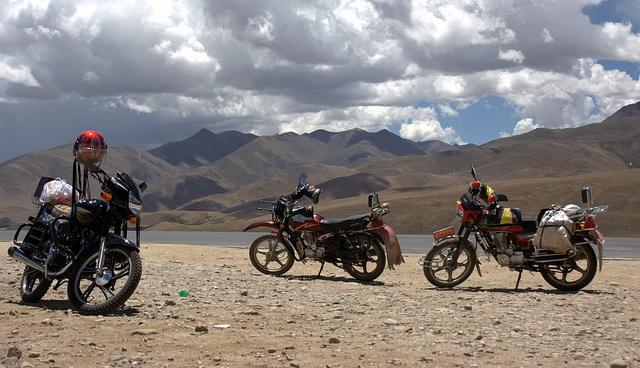Describe the objects in this image and their specific colors. I can see motorcycle in lightgray, black, gray, darkgray, and maroon tones, motorcycle in lightgray, black, gray, and maroon tones, and motorcycle in lightgray, black, gray, and maroon tones in this image. 